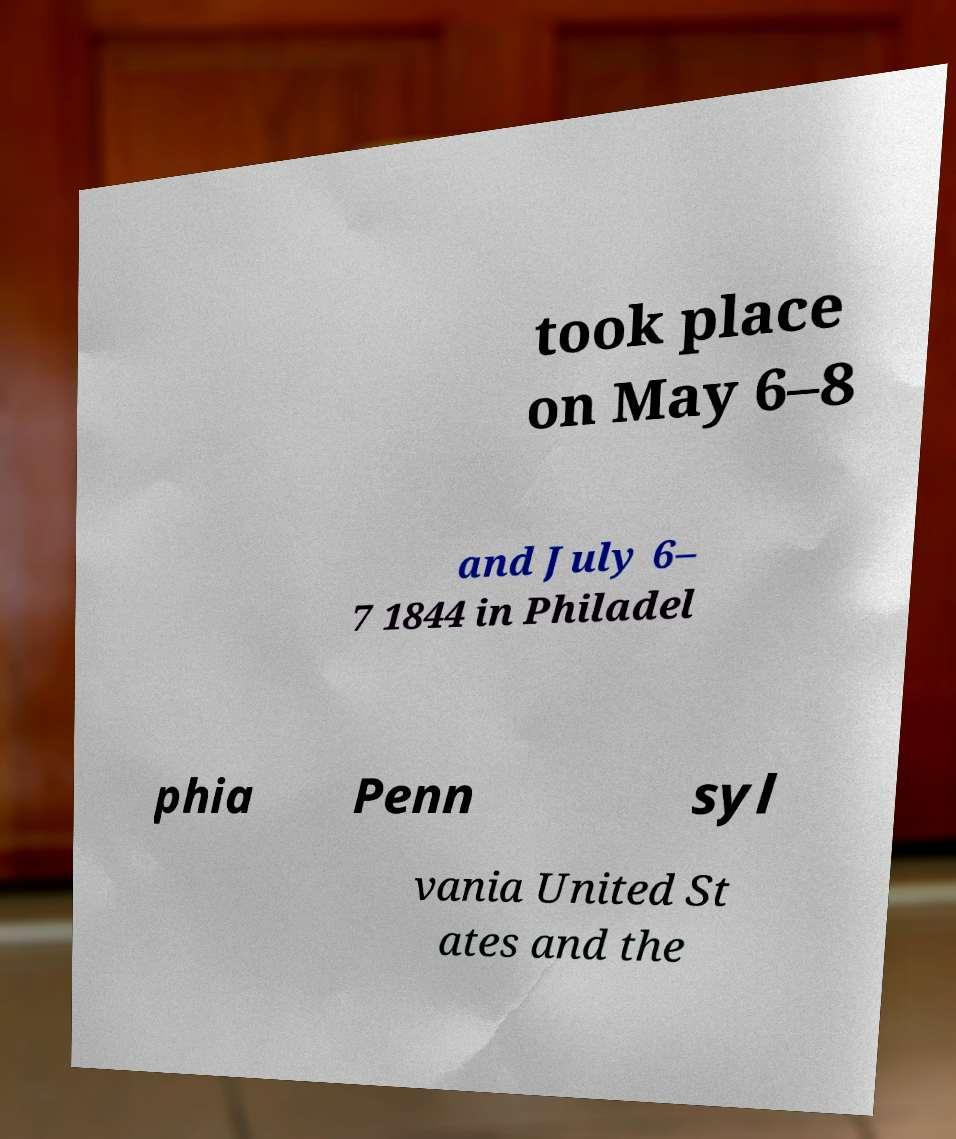There's text embedded in this image that I need extracted. Can you transcribe it verbatim? took place on May 6–8 and July 6– 7 1844 in Philadel phia Penn syl vania United St ates and the 